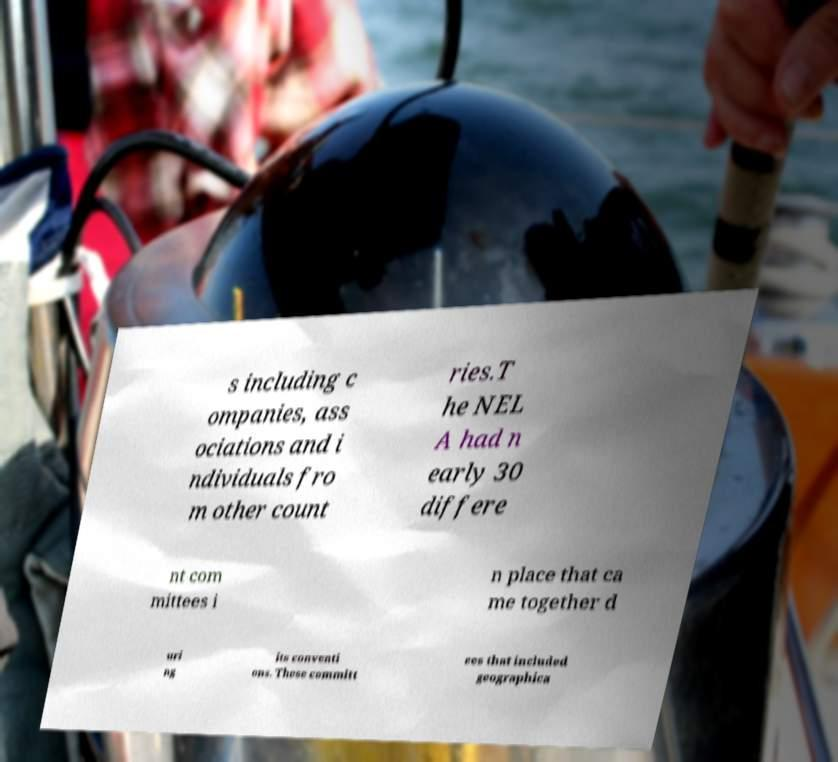Please read and relay the text visible in this image. What does it say? s including c ompanies, ass ociations and i ndividuals fro m other count ries.T he NEL A had n early 30 differe nt com mittees i n place that ca me together d uri ng its conventi ons. These committ ees that included geographica 